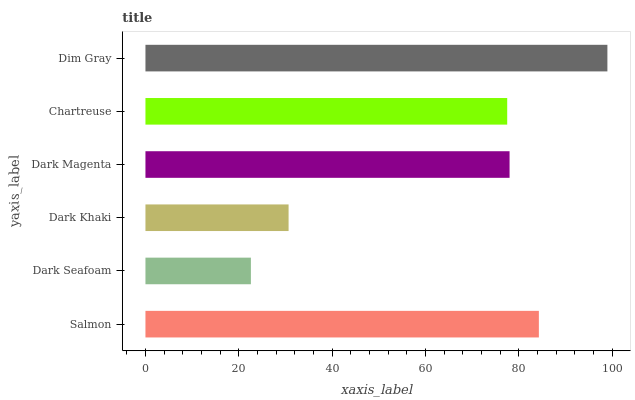Is Dark Seafoam the minimum?
Answer yes or no. Yes. Is Dim Gray the maximum?
Answer yes or no. Yes. Is Dark Khaki the minimum?
Answer yes or no. No. Is Dark Khaki the maximum?
Answer yes or no. No. Is Dark Khaki greater than Dark Seafoam?
Answer yes or no. Yes. Is Dark Seafoam less than Dark Khaki?
Answer yes or no. Yes. Is Dark Seafoam greater than Dark Khaki?
Answer yes or no. No. Is Dark Khaki less than Dark Seafoam?
Answer yes or no. No. Is Dark Magenta the high median?
Answer yes or no. Yes. Is Chartreuse the low median?
Answer yes or no. Yes. Is Dark Seafoam the high median?
Answer yes or no. No. Is Dark Khaki the low median?
Answer yes or no. No. 